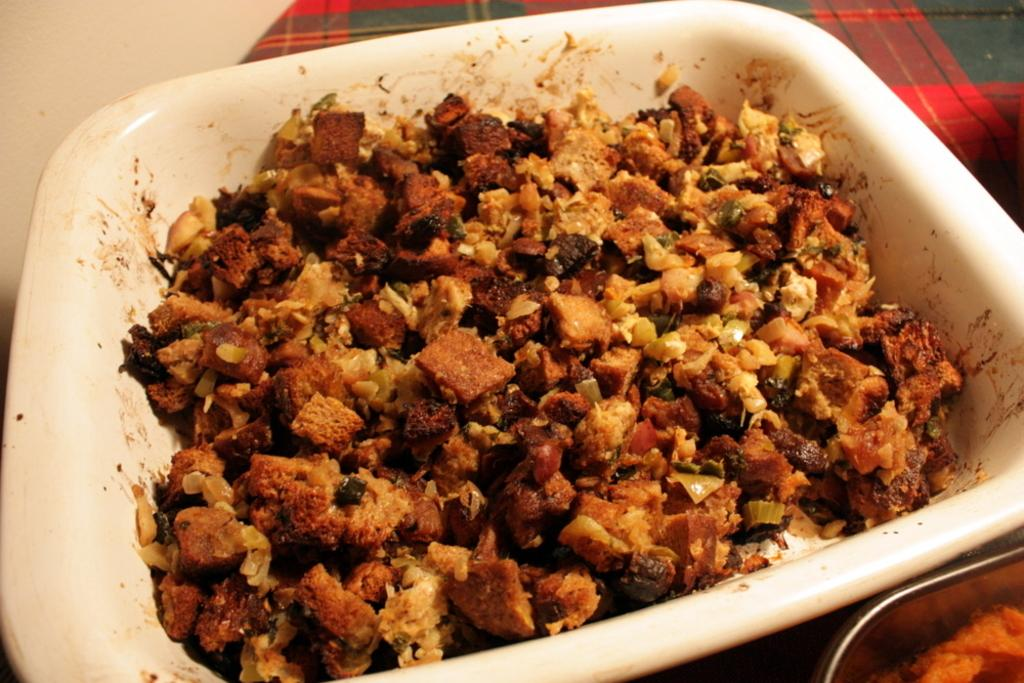What is the main object in the center of the image? There is a white color palette in the center of the image. What is on the palette? The palette contains food items. What can be seen on the right side of the image? There is a cloth on the right side of the image, and there are other objects visible as well. How many bells are hanging from the cloth on the right side of the image? There are no bells visible in the image; the cloth and other objects do not include bells. 